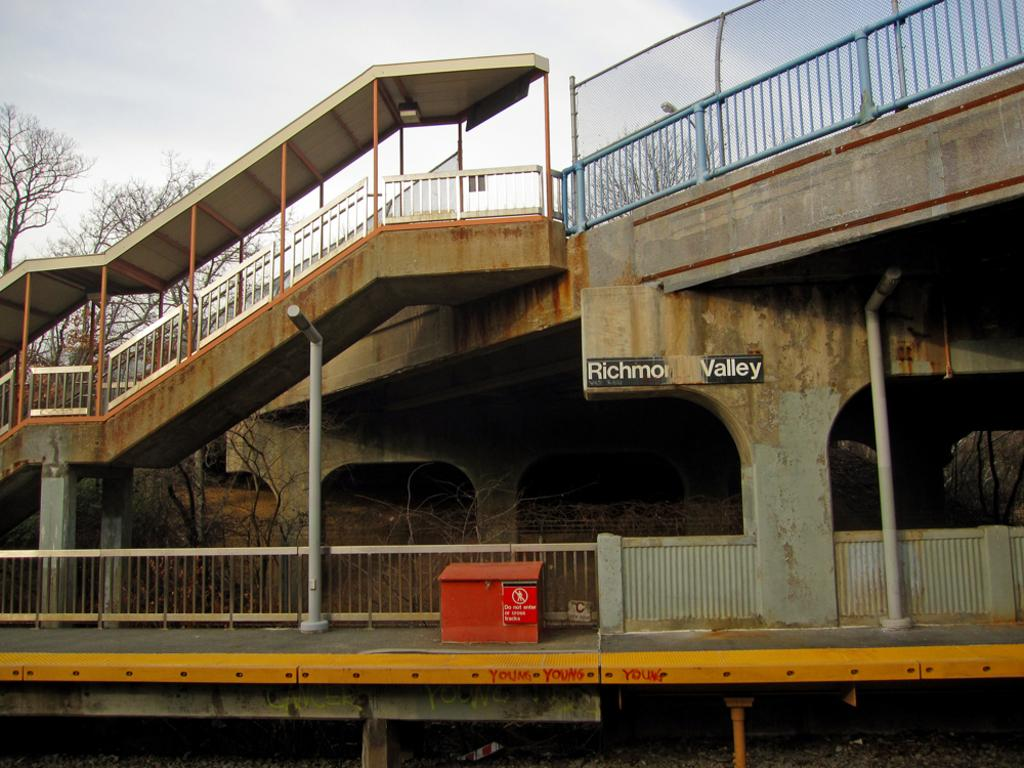What type of structure can be seen in the image? There is a bridge in the image. What type of barriers are present in the image? There are fences in the image. What are the vertical supports in the image? There are poles in the image. What is placed on a platform in the image? There is a box on a platform in the image. What is written on the wall in the image? There is a name board on the wall in the image. What type of vegetation is visible in the image? There are trees in the image. What other objects can be seen in the image? There are some objects in the image. What can be seen in the background of the image? The sky is visible in the background of the image. What type of flowers are growing on the bridge in the image? There are no flowers present on the bridge in the image. How does the flock of birds fly over the bridge in the image? There are no birds or flocks visible in the image. 